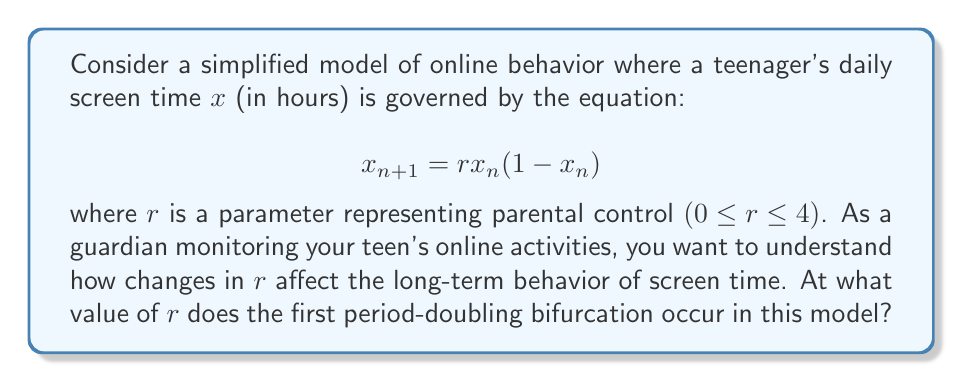Provide a solution to this math problem. To find the first period-doubling bifurcation point, we need to follow these steps:

1) In the logistic map $x_{n+1} = rx_n(1-x_n)$, the fixed points are given by solving $x = rx(1-x)$.

2) Solving this equation:
   $x = rx - rx^2$
   $rx^2 - rx + x = 0$
   $x(rx - r + 1) = 0$

   So, $x = 0$ or $x = 1 - \frac{1}{r}$

3) The non-zero fixed point $x^* = 1 - \frac{1}{r}$ is stable when $|\frac{df}{dx}| < 1$ at $x = x^*$.

4) Calculate $\frac{df}{dx}$:
   $\frac{df}{dx} = r(1-2x)$

5) Evaluate at $x^*$:
   $\frac{df}{dx}|_{x^*} = r(1-2(1-\frac{1}{r})) = r(1-2+\frac{2}{r}) = 2-r$

6) For stability, we need $|2-r| < 1$, which means $1 < r < 3$.

7) The period-doubling bifurcation occurs when $\frac{df}{dx}|_{x^*} = -1$:
   $2-r = -1$
   $r = 3$

Therefore, the first period-doubling bifurcation occurs at $r = 3$.
Answer: $r = 3$ 